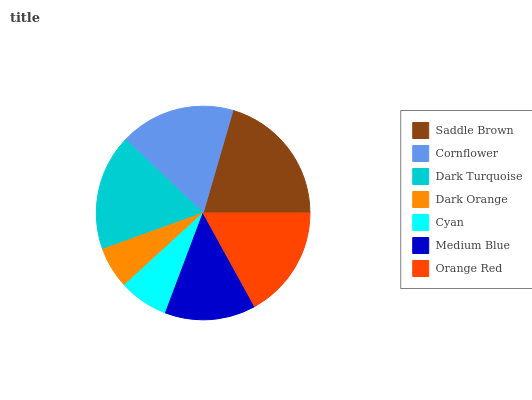Is Dark Orange the minimum?
Answer yes or no. Yes. Is Saddle Brown the maximum?
Answer yes or no. Yes. Is Cornflower the minimum?
Answer yes or no. No. Is Cornflower the maximum?
Answer yes or no. No. Is Saddle Brown greater than Cornflower?
Answer yes or no. Yes. Is Cornflower less than Saddle Brown?
Answer yes or no. Yes. Is Cornflower greater than Saddle Brown?
Answer yes or no. No. Is Saddle Brown less than Cornflower?
Answer yes or no. No. Is Orange Red the high median?
Answer yes or no. Yes. Is Orange Red the low median?
Answer yes or no. Yes. Is Medium Blue the high median?
Answer yes or no. No. Is Cornflower the low median?
Answer yes or no. No. 